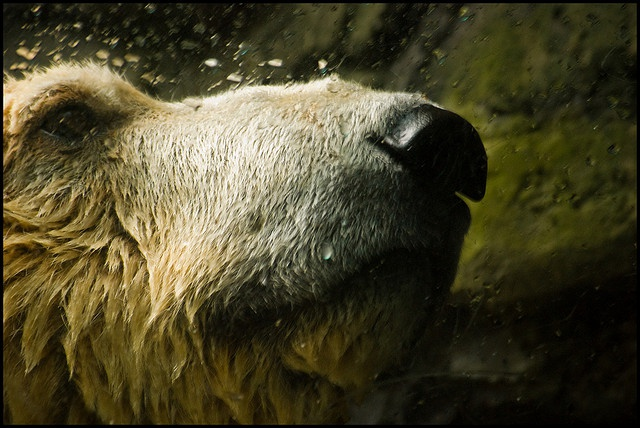Describe the objects in this image and their specific colors. I can see a bear in black, olive, and tan tones in this image. 